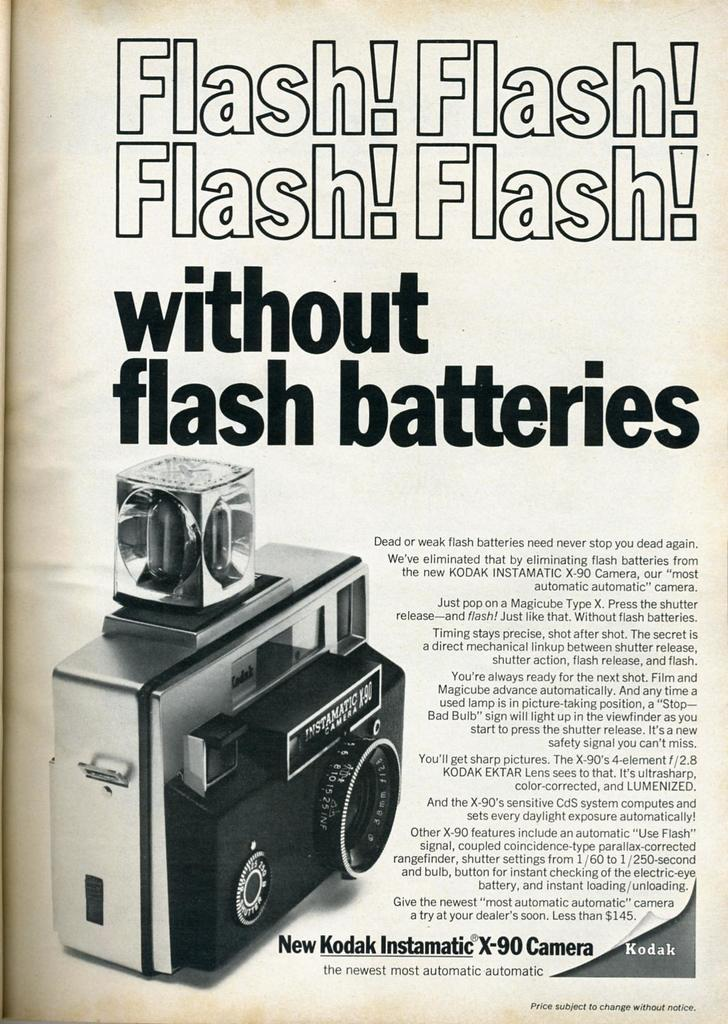What is the main subject of the image? The main subject of the image is a page. What is shown on the page? There is a camera depicted on the page. Are there any words or letters on the page? Yes, there is text on the page. What type of crayon is being used to draw the camera on the page? There is no crayon present in the image, and the camera is not being drawn; it is depicted as a photograph or illustration. 